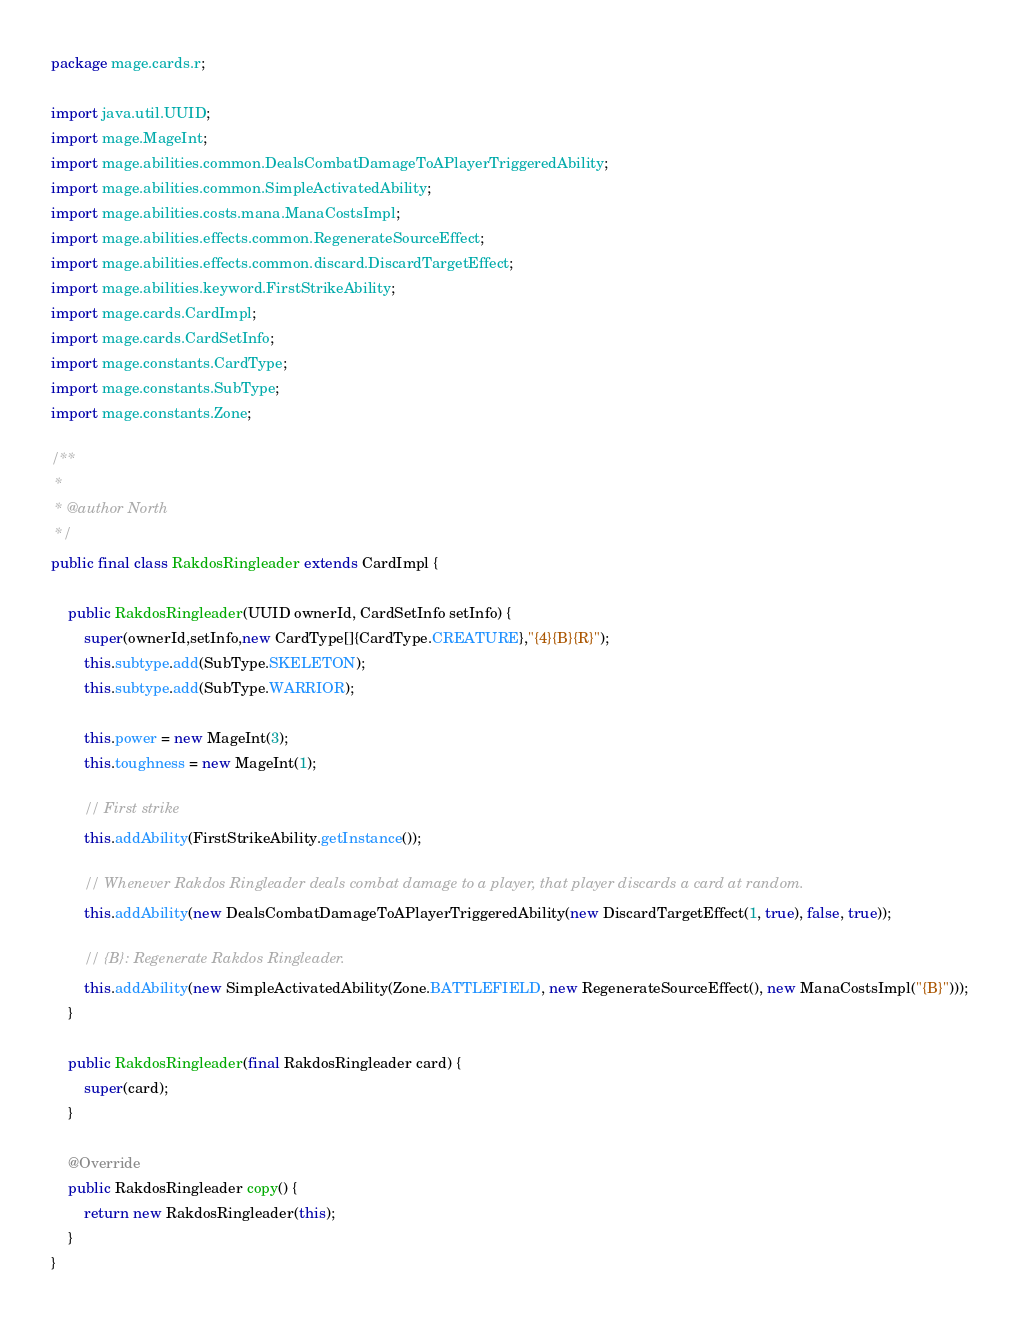Convert code to text. <code><loc_0><loc_0><loc_500><loc_500><_Java_>
package mage.cards.r;

import java.util.UUID;
import mage.MageInt;
import mage.abilities.common.DealsCombatDamageToAPlayerTriggeredAbility;
import mage.abilities.common.SimpleActivatedAbility;
import mage.abilities.costs.mana.ManaCostsImpl;
import mage.abilities.effects.common.RegenerateSourceEffect;
import mage.abilities.effects.common.discard.DiscardTargetEffect;
import mage.abilities.keyword.FirstStrikeAbility;
import mage.cards.CardImpl;
import mage.cards.CardSetInfo;
import mage.constants.CardType;
import mage.constants.SubType;
import mage.constants.Zone;

/**
 *
 * @author North
 */
public final class RakdosRingleader extends CardImpl {

    public RakdosRingleader(UUID ownerId, CardSetInfo setInfo) {
        super(ownerId,setInfo,new CardType[]{CardType.CREATURE},"{4}{B}{R}");
        this.subtype.add(SubType.SKELETON);
        this.subtype.add(SubType.WARRIOR);

        this.power = new MageInt(3);
        this.toughness = new MageInt(1);

        // First strike
        this.addAbility(FirstStrikeAbility.getInstance());
        
        // Whenever Rakdos Ringleader deals combat damage to a player, that player discards a card at random.
        this.addAbility(new DealsCombatDamageToAPlayerTriggeredAbility(new DiscardTargetEffect(1, true), false, true));
        
        // {B}: Regenerate Rakdos Ringleader.
        this.addAbility(new SimpleActivatedAbility(Zone.BATTLEFIELD, new RegenerateSourceEffect(), new ManaCostsImpl("{B}")));
    }

    public RakdosRingleader(final RakdosRingleader card) {
        super(card);
    }

    @Override
    public RakdosRingleader copy() {
        return new RakdosRingleader(this);
    }
}
</code> 